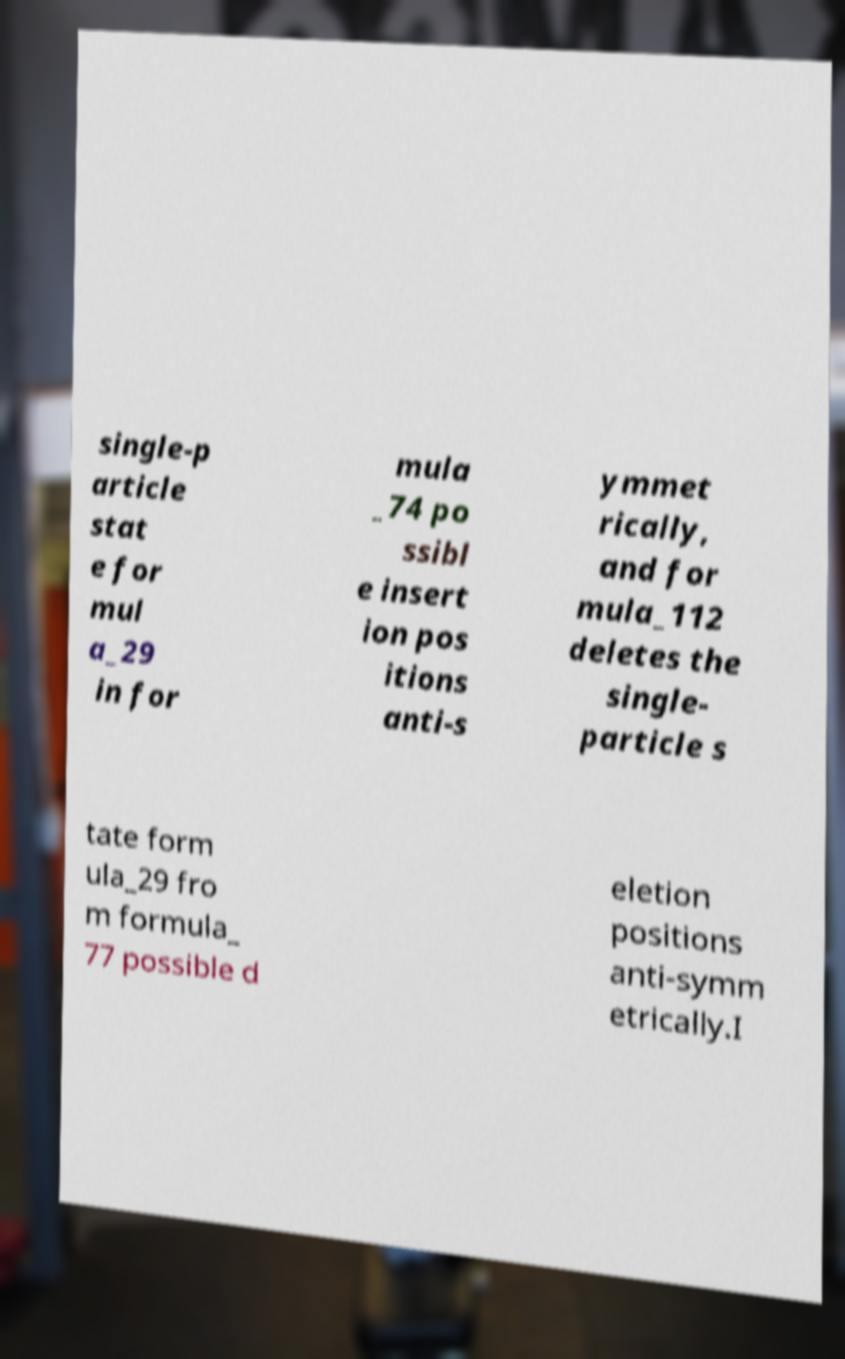Could you extract and type out the text from this image? single-p article stat e for mul a_29 in for mula _74 po ssibl e insert ion pos itions anti-s ymmet rically, and for mula_112 deletes the single- particle s tate form ula_29 fro m formula_ 77 possible d eletion positions anti-symm etrically.I 